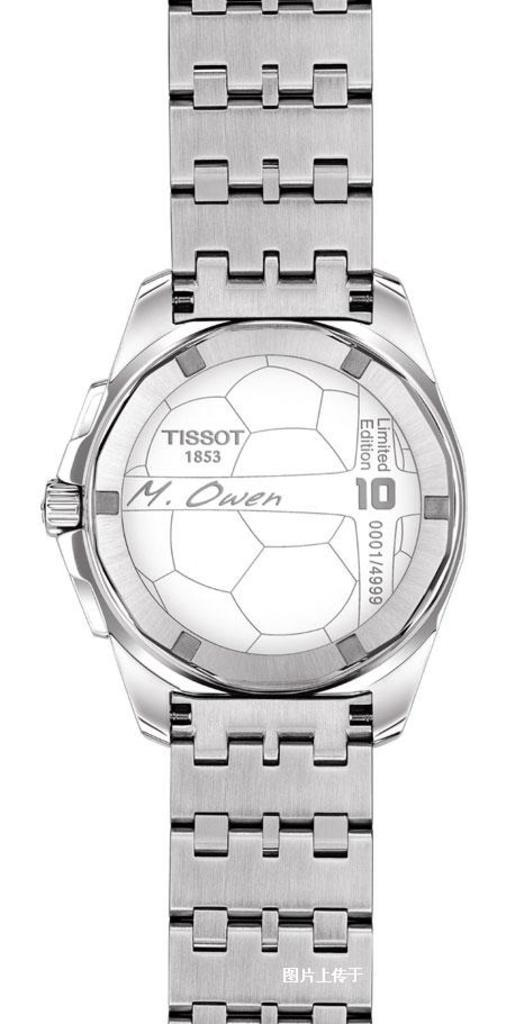<image>
Give a short and clear explanation of the subsequent image. A silver Tissot 1853 wristwatch with a geometric design on its face. 